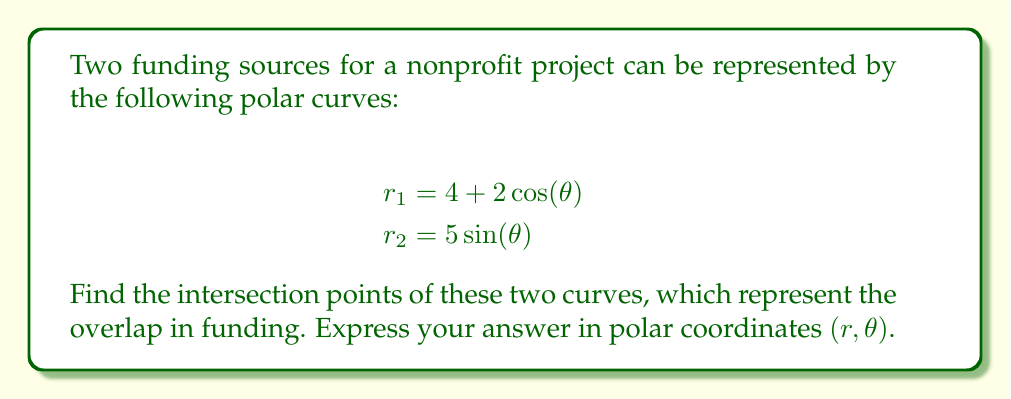Help me with this question. To find the intersection points of these two polar curves, we need to follow these steps:

1) Set the equations equal to each other:
   $4 + 2\cos(\theta) = 5\sin(\theta)$

2) Rearrange the equation:
   $2\cos(\theta) - 5\sin(\theta) = -4$

3) Use the identity $a\cos(\theta) + b\sin(\theta) = \sqrt{a^2+b^2}\cos(\theta-\arctan(\frac{b}{a}))$:
   $\sqrt{4+25}\cos(\theta-\arctan(\frac{-5}{2})) = -4$
   $\sqrt{29}\cos(\theta+\arctan(\frac{5}{2})) = -4$

4) Solve for $\theta$:
   $\cos(\theta+\arctan(\frac{5}{2})) = -\frac{4}{\sqrt{29}}$
   $\theta+\arctan(\frac{5}{2}) = \arccos(-\frac{4}{\sqrt{29}})$ or $2\pi - \arccos(-\frac{4}{\sqrt{29}})$

   $\theta_1 = \arccos(-\frac{4}{\sqrt{29}}) - \arctan(\frac{5}{2})$
   $\theta_2 = 2\pi - \arccos(-\frac{4}{\sqrt{29}}) - \arctan(\frac{5}{2})$

5) Calculate $r$ for each $\theta$ using either of the original equations:
   $r_1 = 4 + 2\cos(\theta_1)$
   $r_2 = 4 + 2\cos(\theta_2)$

6) Convert to degrees for easier interpretation:
   $\theta_1 \approx 0.5821$ radians $\approx 33.36°$
   $\theta_2 \approx 5.7012$ radians $\approx 326.64°$

   $r_1 \approx 5.6569$
   $r_2 \approx 5.6569$
Answer: The intersection points are approximately $(5.6569, 33.36°)$ and $(5.6569, 326.64°)$ in polar coordinates $(r,\theta)$. 